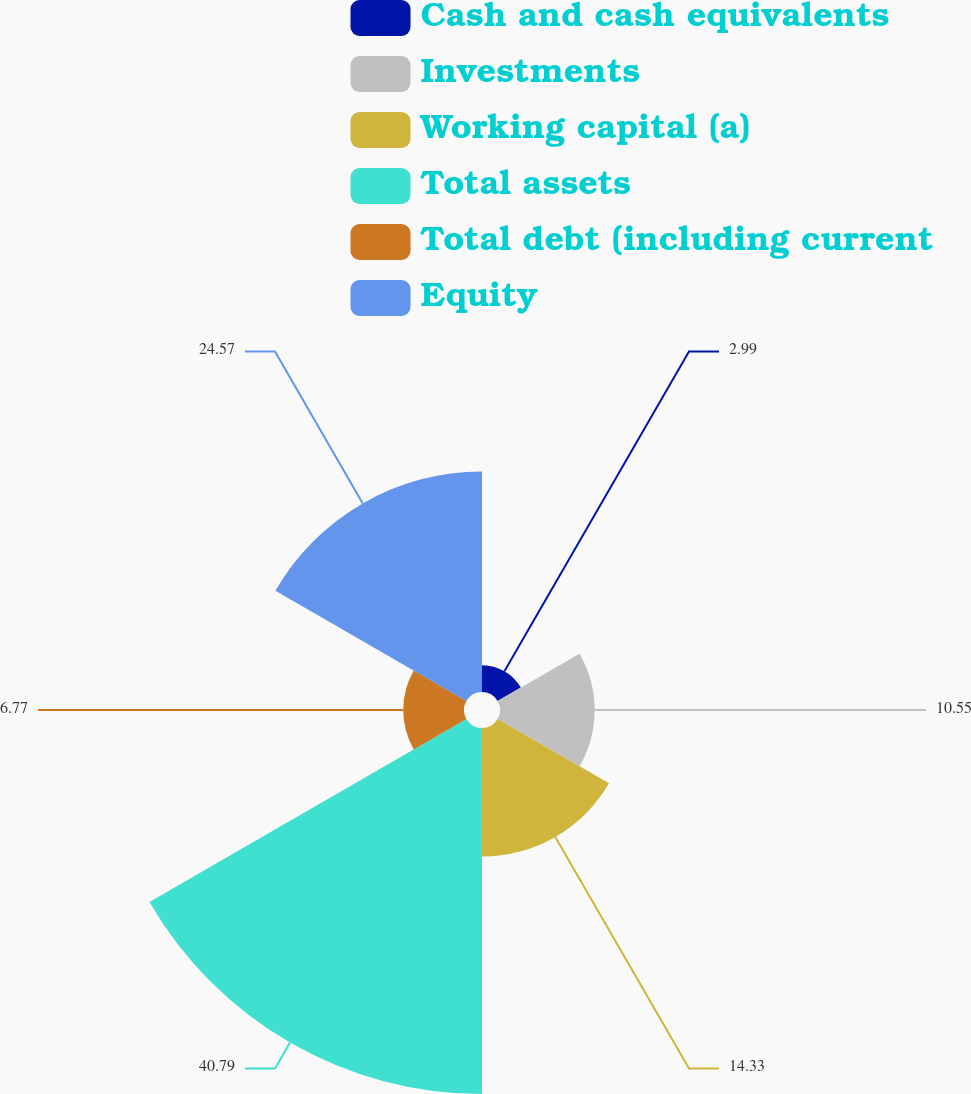Convert chart. <chart><loc_0><loc_0><loc_500><loc_500><pie_chart><fcel>Cash and cash equivalents<fcel>Investments<fcel>Working capital (a)<fcel>Total assets<fcel>Total debt (including current<fcel>Equity<nl><fcel>2.99%<fcel>10.55%<fcel>14.33%<fcel>40.78%<fcel>6.77%<fcel>24.57%<nl></chart> 